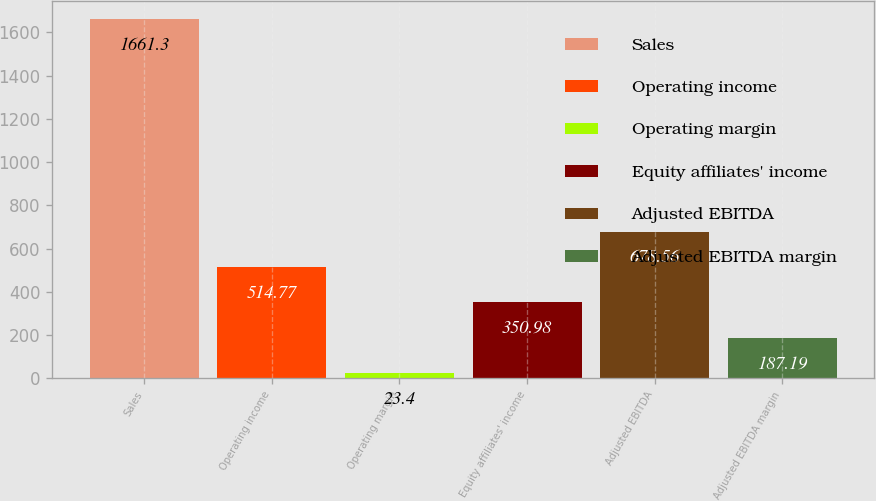Convert chart. <chart><loc_0><loc_0><loc_500><loc_500><bar_chart><fcel>Sales<fcel>Operating income<fcel>Operating margin<fcel>Equity affiliates' income<fcel>Adjusted EBITDA<fcel>Adjusted EBITDA margin<nl><fcel>1661.3<fcel>514.77<fcel>23.4<fcel>350.98<fcel>678.56<fcel>187.19<nl></chart> 